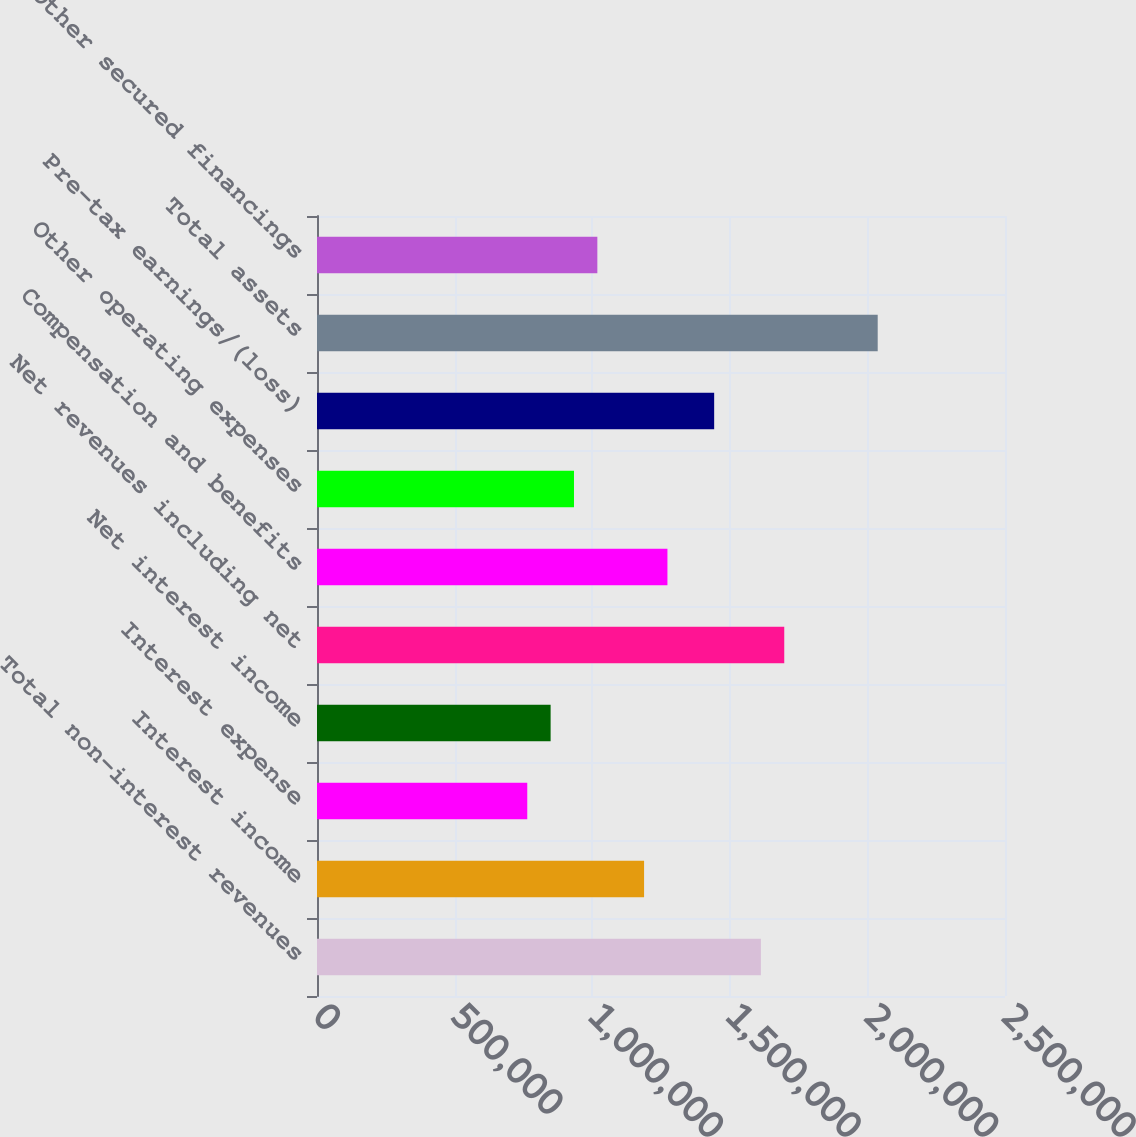Convert chart to OTSL. <chart><loc_0><loc_0><loc_500><loc_500><bar_chart><fcel>Total non-interest revenues<fcel>Interest income<fcel>Interest expense<fcel>Net interest income<fcel>Net revenues including net<fcel>Compensation and benefits<fcel>Other operating expenses<fcel>Pre-tax earnings/(loss)<fcel>Total assets<fcel>Other secured financings<nl><fcel>1.61297e+06<fcel>1.18851e+06<fcel>764050<fcel>848942<fcel>1.69786e+06<fcel>1.2734e+06<fcel>933834<fcel>1.44319e+06<fcel>2.03743e+06<fcel>1.01873e+06<nl></chart> 